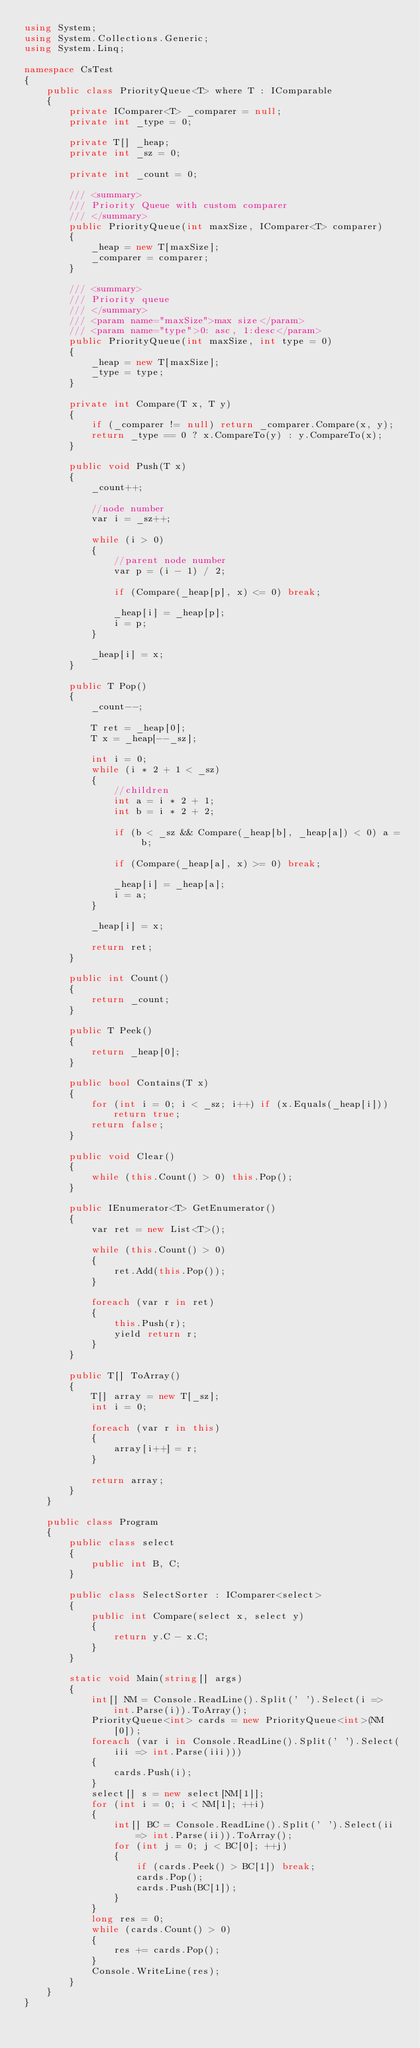<code> <loc_0><loc_0><loc_500><loc_500><_C#_>using System;
using System.Collections.Generic;
using System.Linq;

namespace CsTest
{
    public class PriorityQueue<T> where T : IComparable
    {
        private IComparer<T> _comparer = null;
        private int _type = 0;

        private T[] _heap;
        private int _sz = 0;

        private int _count = 0;

        /// <summary>
        /// Priority Queue with custom comparer
        /// </summary>
        public PriorityQueue(int maxSize, IComparer<T> comparer)
        {
            _heap = new T[maxSize];
            _comparer = comparer;
        }

        /// <summary>
        /// Priority queue
        /// </summary>
        /// <param name="maxSize">max size</param>
        /// <param name="type">0: asc, 1:desc</param>
        public PriorityQueue(int maxSize, int type = 0)
        {
            _heap = new T[maxSize];
            _type = type;
        }

        private int Compare(T x, T y)
        {
            if (_comparer != null) return _comparer.Compare(x, y);
            return _type == 0 ? x.CompareTo(y) : y.CompareTo(x);
        }

        public void Push(T x)
        {
            _count++;

            //node number
            var i = _sz++;

            while (i > 0)
            {
                //parent node number
                var p = (i - 1) / 2;

                if (Compare(_heap[p], x) <= 0) break;

                _heap[i] = _heap[p];
                i = p;
            }

            _heap[i] = x;
        }

        public T Pop()
        {
            _count--;

            T ret = _heap[0];
            T x = _heap[--_sz];

            int i = 0;
            while (i * 2 + 1 < _sz)
            {
                //children
                int a = i * 2 + 1;
                int b = i * 2 + 2;

                if (b < _sz && Compare(_heap[b], _heap[a]) < 0) a = b;

                if (Compare(_heap[a], x) >= 0) break;

                _heap[i] = _heap[a];
                i = a;
            }

            _heap[i] = x;

            return ret;
        }

        public int Count()
        {
            return _count;
        }

        public T Peek()
        {
            return _heap[0];
        }

        public bool Contains(T x)
        {
            for (int i = 0; i < _sz; i++) if (x.Equals(_heap[i])) return true;
            return false;
        }

        public void Clear()
        {
            while (this.Count() > 0) this.Pop();
        }

        public IEnumerator<T> GetEnumerator()
        {
            var ret = new List<T>();

            while (this.Count() > 0)
            {
                ret.Add(this.Pop());
            }

            foreach (var r in ret)
            {
                this.Push(r);
                yield return r;
            }
        }

        public T[] ToArray()
        {
            T[] array = new T[_sz];
            int i = 0;

            foreach (var r in this)
            {
                array[i++] = r;
            }

            return array;
        }
    }

    public class Program
    {
        public class select
        {
            public int B, C;
        }

        public class SelectSorter : IComparer<select>
        {
            public int Compare(select x, select y)
            {
                return y.C - x.C;
            }
        }

        static void Main(string[] args)
        {
            int[] NM = Console.ReadLine().Split(' ').Select(i => int.Parse(i)).ToArray();
            PriorityQueue<int> cards = new PriorityQueue<int>(NM[0]);
            foreach (var i in Console.ReadLine().Split(' ').Select(iii => int.Parse(iii)))
            {
                cards.Push(i);
            }
            select[] s = new select[NM[1]];
            for (int i = 0; i < NM[1]; ++i)
            {
                int[] BC = Console.ReadLine().Split(' ').Select(ii => int.Parse(ii)).ToArray();
                for (int j = 0; j < BC[0]; ++j)
                {
                    if (cards.Peek() > BC[1]) break;
                    cards.Pop();
                    cards.Push(BC[1]);
                }
            }
            long res = 0;
            while (cards.Count() > 0)
            {
                res += cards.Pop();
            }
            Console.WriteLine(res);
        }
    }
}</code> 